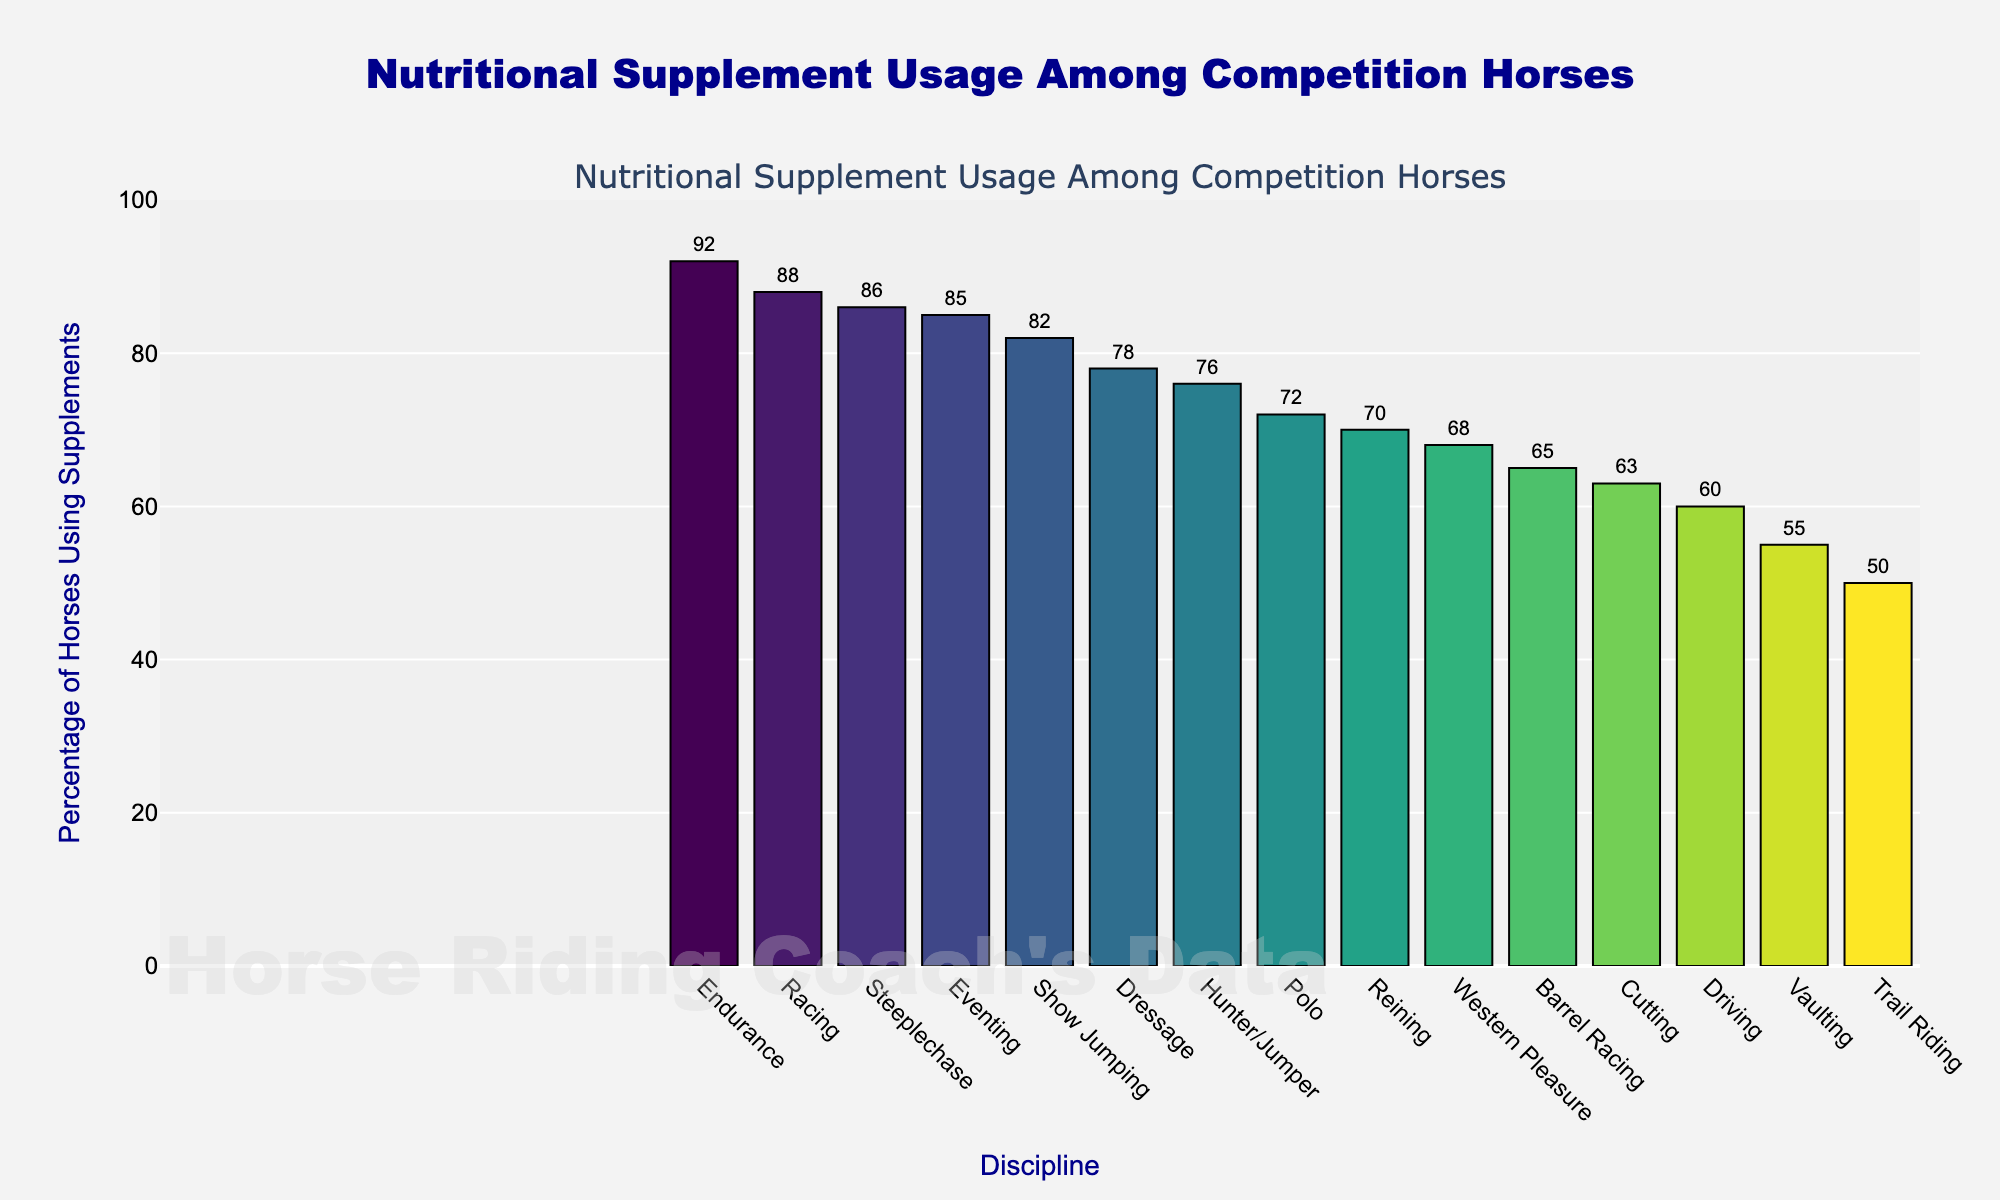Which discipline has the highest percentage of horses using supplements? The highest bar represents the discipline with the highest usage. Here, the largest bar corresponds to Endurance.
Answer: Endurance Which discipline has the lowest percentage of horses using supplements? The lowest bar represents the discipline with the lowest usage. Here, the smallest bar corresponds to Vaulting.
Answer: Vaulting What is the difference in supplement usage percentages between Eventing and Reining? The percentage for Eventing is 85%, and for Reining, it is 70%. Subtract 70% from 85%.
Answer: 15% Which disciplines have a supplement usage percentage higher than 80%? Identify all bars whose heights correspond to percentages over 80%. These are Show Jumping, Eventing, Endurance, Racing, and Steeplechase.
Answer: Show Jumping, Eventing, Endurance, Racing, Steeplechase What is the average percentage of supplement usage among disciplines with more than 75% usage? Calculate the average for: Dressage (78), Show Jumping (82), Eventing (85), Endurance (92), Racing (88), Steeplechase (86). Sum these and divide by the count (6).
Answer: 85.17% Which discipline comes immediately after Show Jumping in terms of supplement usage percentage? Locate Show Jumping on the bar chart and see the next highest bar. Eventing follows Show Jumping.
Answer: Eventing How many disciplines have a supplement usage percentage less than 70%? Count the bars with heights corresponding to percentages below 70%. These are Barrel Racing, Driving, Vaulting, Trail Riding, Western Pleasure, and Cutting.
Answer: 6 What percentage of horses in Dressage use supplements? Identify the height of the bar corresponding to Dressage.
Answer: 78% Is the supplement usage percentage for Trail Riding more or less than 60%? Compare the height of the Trail Riding bar with the 60% mark on the y-axis. It is less.
Answer: Less What is the combined percentage of supplement usage for Barrel Racing and Polo? Add the percentages for Barrel Racing (65%) and Polo (72%).
Answer: 137% 